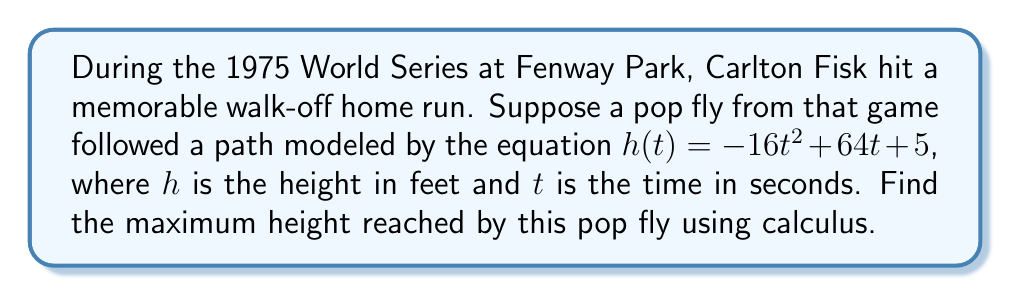Can you solve this math problem? To find the maximum height of the pop fly, we need to follow these steps:

1) The function $h(t) = -16t^2 + 64t + 5$ represents the height of the ball over time.

2) To find the maximum height, we need to find the critical point where the derivative equals zero.

3) Let's find the derivative of $h(t)$:
   $$h'(t) = -32t + 64$$

4) Set the derivative equal to zero and solve for $t$:
   $$-32t + 64 = 0$$
   $$-32t = -64$$
   $$t = 2$$

5) This critical point $t = 2$ could be a maximum, minimum, or inflection point. To confirm it's a maximum, we can check the second derivative:
   $$h''(t) = -32$$

   Since $h''(t)$ is negative for all $t$, the critical point is indeed a maximum.

6) To find the maximum height, we plug $t = 2$ back into our original function:
   $$h(2) = -16(2)^2 + 64(2) + 5$$
   $$= -16(4) + 128 + 5$$
   $$= -64 + 128 + 5$$
   $$= 69$$

Therefore, the maximum height reached by the pop fly is 69 feet.
Answer: 69 feet 